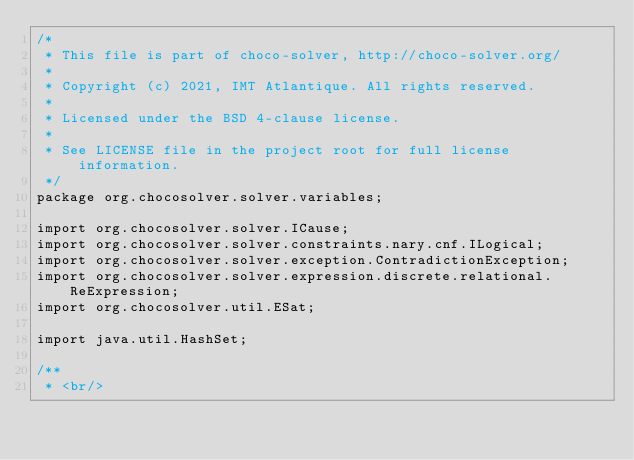Convert code to text. <code><loc_0><loc_0><loc_500><loc_500><_Java_>/*
 * This file is part of choco-solver, http://choco-solver.org/
 *
 * Copyright (c) 2021, IMT Atlantique. All rights reserved.
 *
 * Licensed under the BSD 4-clause license.
 *
 * See LICENSE file in the project root for full license information.
 */
package org.chocosolver.solver.variables;

import org.chocosolver.solver.ICause;
import org.chocosolver.solver.constraints.nary.cnf.ILogical;
import org.chocosolver.solver.exception.ContradictionException;
import org.chocosolver.solver.expression.discrete.relational.ReExpression;
import org.chocosolver.util.ESat;

import java.util.HashSet;

/**
 * <br/></code> 